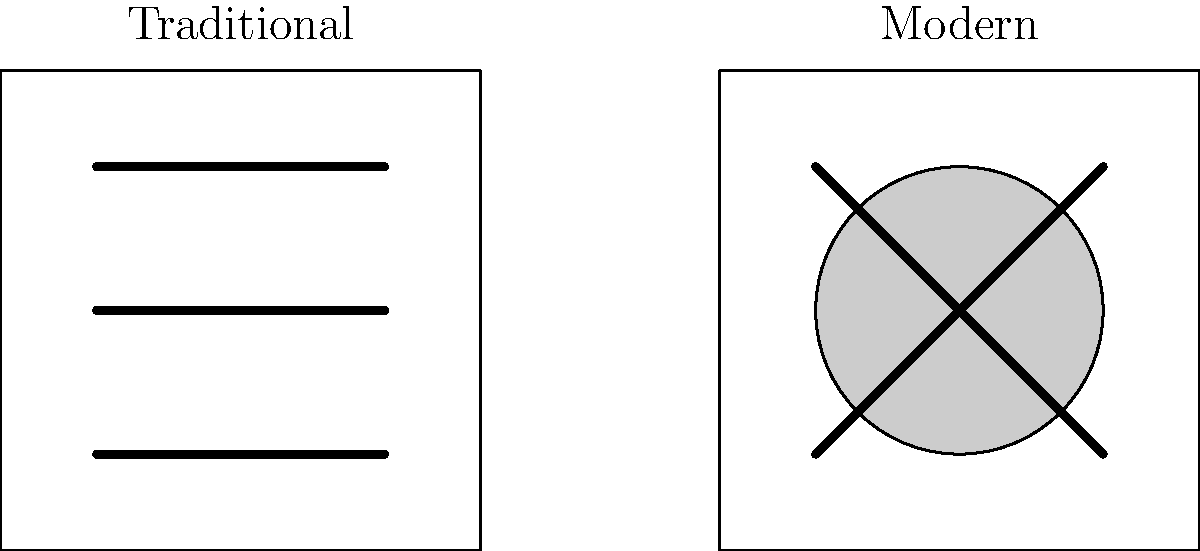Based on the illustration, which artistic approach is more likely to be used in depicting trauma-related experiences in contemporary art therapy, and why? To answer this question, let's analyze the characteristics of both traditional and modern art techniques as depicted in the illustration:

1. Traditional technique:
   - Represented by straight, parallel lines
   - Suggests a more structured, orderly approach
   - Implies a focus on realism and precise representation

2. Modern technique:
   - Depicted with a circle and intersecting lines
   - Indicates a more abstract, fluid approach
   - Suggests freedom of expression and interpretation

3. Trauma-related experiences:
   - Often complex and difficult to articulate verbally
   - May involve fragmented memories or emotions
   - Require a safe space for expression without judgment

4. Art therapy in contemporary practice:
   - Emphasizes personal expression over technical skill
   - Encourages exploration of emotions and experiences
   - Values the process of creation as much as the final product

5. Suitability for trauma-related art therapy:
   - Modern technique allows for:
     a) Abstract representation of complex emotions
     b) Non-literal expression of experiences
     c) Freedom to explore and process trauma without constraints

Given these factors, the modern art technique is more likely to be used in depicting trauma-related experiences in contemporary art therapy. Its abstract nature provides a safer, more flexible medium for expressing and processing complex trauma-related emotions and memories.
Answer: Modern technique, due to its abstract and flexible nature allowing for freer expression of complex trauma-related emotions. 